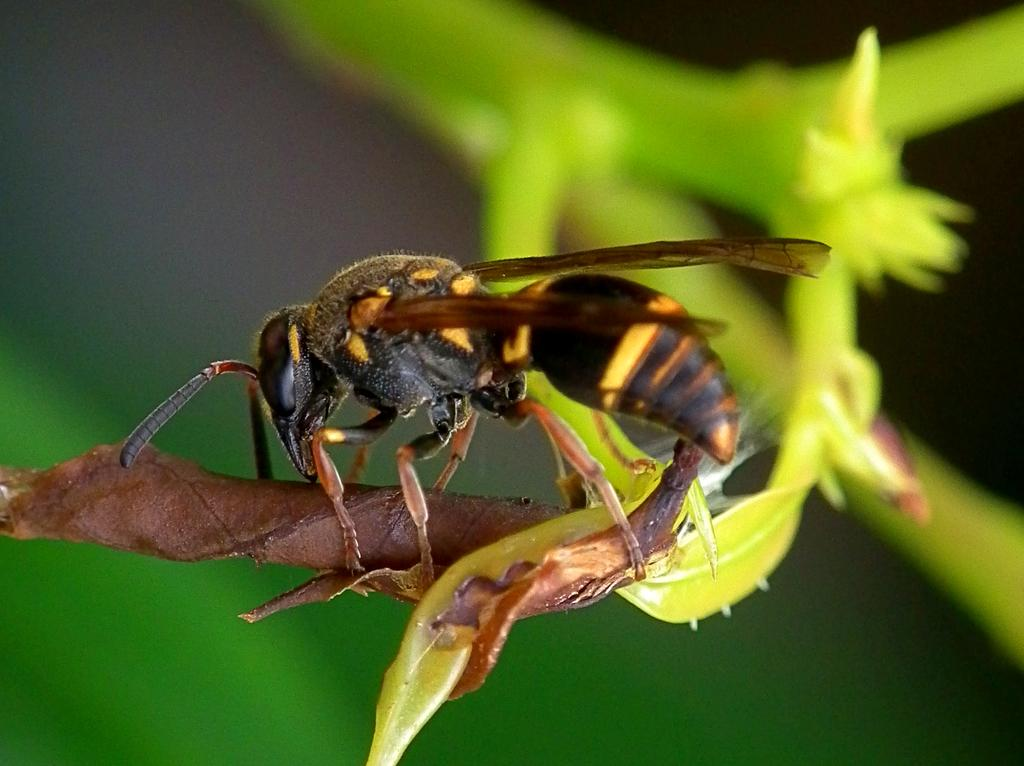What is the main subject in the foreground of the picture? There is an insect in the foreground of the picture. Where is the insect located? The insect is on a stem. What can be observed about the background of the image? The background of the image is blurred. What type of food is the insect eating in the picture? There is no food visible in the image, and the insect is not shown eating anything. 